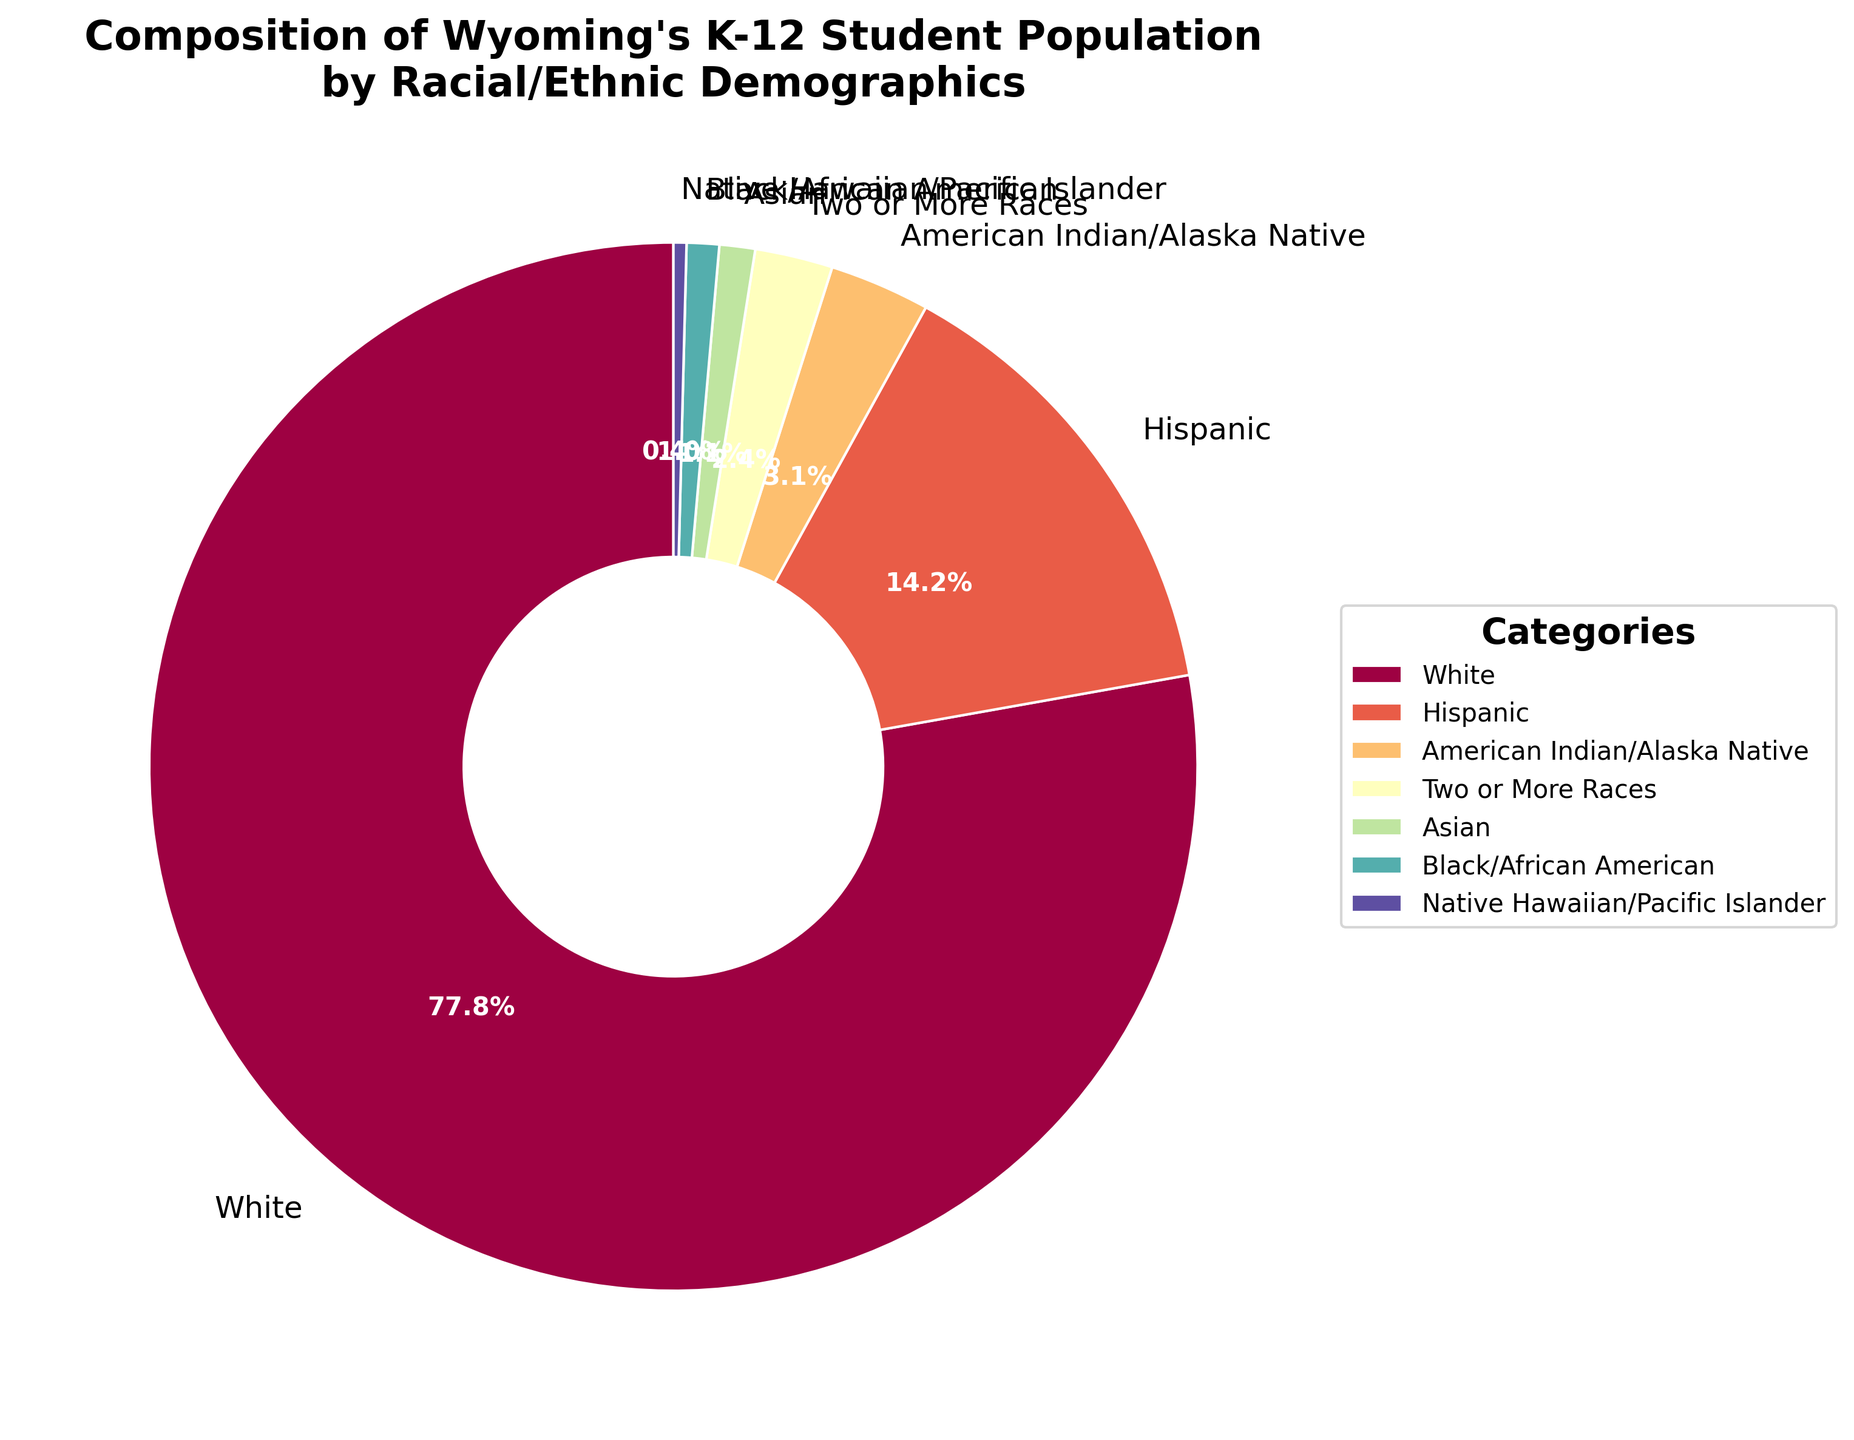What's the percentage difference between the White and Hispanic student populations? The percentage of White students is 77.8%, and the percentage of Hispanic students is 14.2%. The difference is calculated as 77.8% - 14.2%.
Answer: 63.6% Which group has the smallest representation in Wyoming's K-12 student population? By examining the pie chart, the group with the smallest percentage is Native Hawaiian/Pacific Islander at 0.4%.
Answer: Native Hawaiian/Pacific Islander What is the combined percentage of students who identify as Asian, Black/African American, and Native Hawaiian/Pacific Islander? The percentages for Asian, Black/African American, and Native Hawaiian/Pacific Islander are 1.1%, 1.0%, and 0.4%, respectively. Adding them up gives 1.1% + 1.0% + 0.4%.
Answer: 2.5% Is the percentage of students identifying as Two or More Races greater than those identifying as Black/African American? The percentage for Two or More Races is 2.4%, while for Black/African American it's 1.0%. 2.4% > 1.0%.
Answer: Yes What is the median percentage among the racial/ethnic groups listed? The percentages are: 77.8, 14.2, 3.1, 2.4, 1.1, 1.0, 0.4. After sorting: 0.4, 1.0, 1.1, 2.4, 3.1, 14.2, 77.8. The median is the fourth value in this list.
Answer: 2.4 Out of the racial/ethnic groups listed, how many have a percentage greater than 10%? Examining the chart, the groups greater than 10% are White (77.8%) and Hispanic (14.2%). Count: 2.
Answer: 2 What is the percentage difference between American Indian/Alaska Native students and Two or More Races students? The percentage of American Indian/Alaska Native students is 3.1%, and Two or More Races is 2.4%. The difference is 3.1% - 2.4%.
Answer: 0.7% Which racial/ethnic group has closer representation to Black/African American compared to Asian? The percentage for Black/African American is 1.0%, and for Asian it's 1.1%. Examining other percentages, Two or More Races is 2.4%. Since 1.1% is closest to 1.0%, Black/African American is closer to Asian.
Answer: Asian 